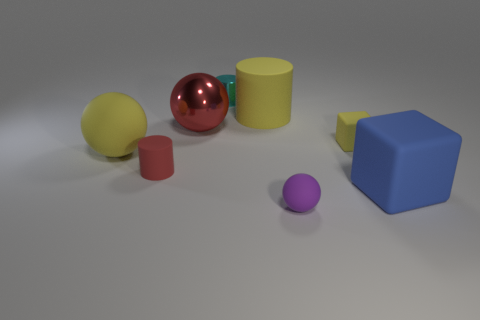Add 1 small cyan cylinders. How many objects exist? 9 Subtract all cylinders. How many objects are left? 5 Subtract 1 yellow balls. How many objects are left? 7 Subtract all big red shiny objects. Subtract all large red balls. How many objects are left? 6 Add 6 small yellow things. How many small yellow things are left? 7 Add 7 large red metal blocks. How many large red metal blocks exist? 7 